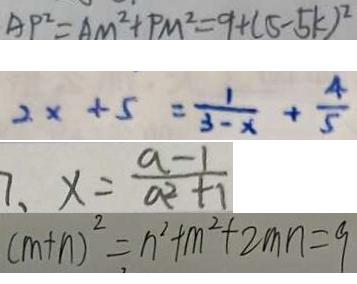Convert formula to latex. <formula><loc_0><loc_0><loc_500><loc_500>A P ^ { 2 } = A M ^ { 2 } + P M ^ { 2 } = 9 + ( 5 - 5 k ) ^ { 2 } 
 2 x + 5 = \frac { 1 } { 3 - x } + \frac { 4 } { 5 } 
 7 、 x = \frac { a - 1 } { a ^ { 2 } + 1 } 
 ( m + n ) ^ { 2 } = n ^ { 2 } + m ^ { 2 } + 2 m n = 9</formula> 